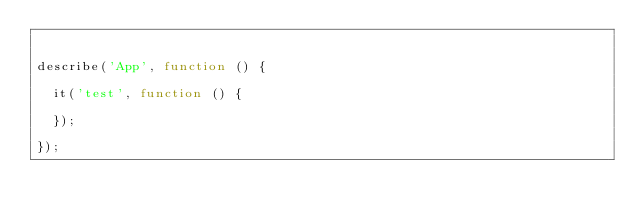<code> <loc_0><loc_0><loc_500><loc_500><_JavaScript_>

describe('App', function () {

  it('test', function () {

  });

});
</code> 